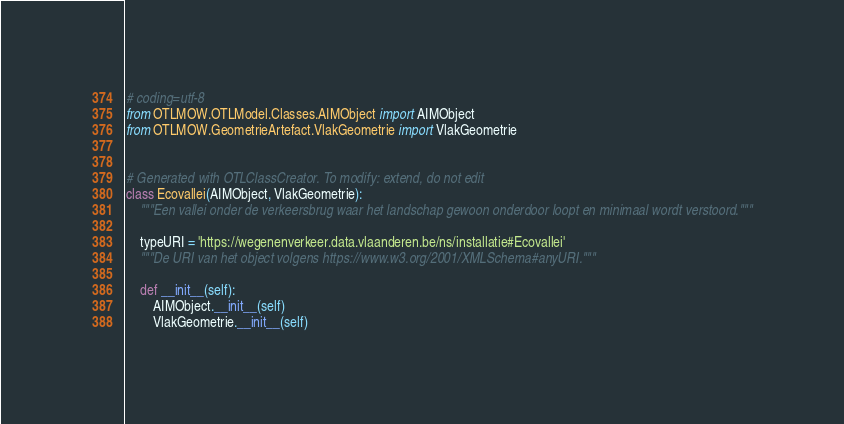<code> <loc_0><loc_0><loc_500><loc_500><_Python_># coding=utf-8
from OTLMOW.OTLModel.Classes.AIMObject import AIMObject
from OTLMOW.GeometrieArtefact.VlakGeometrie import VlakGeometrie


# Generated with OTLClassCreator. To modify: extend, do not edit
class Ecovallei(AIMObject, VlakGeometrie):
    """Een vallei onder de verkeersbrug waar het landschap gewoon onderdoor loopt en minimaal wordt verstoord."""

    typeURI = 'https://wegenenverkeer.data.vlaanderen.be/ns/installatie#Ecovallei'
    """De URI van het object volgens https://www.w3.org/2001/XMLSchema#anyURI."""

    def __init__(self):
        AIMObject.__init__(self)
        VlakGeometrie.__init__(self)
</code> 